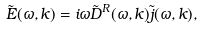Convert formula to latex. <formula><loc_0><loc_0><loc_500><loc_500>\tilde { E } ( \omega , k ) = i \omega \tilde { D } ^ { R } ( \omega , k ) \tilde { j } ( \omega , k ) ,</formula> 